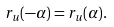<formula> <loc_0><loc_0><loc_500><loc_500>r _ { u } ( - \alpha ) = r _ { u } ( \alpha ) .</formula> 